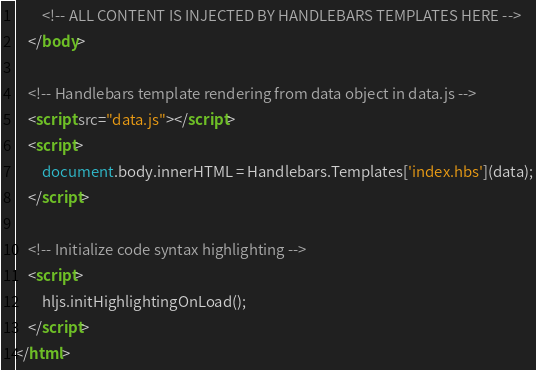Convert code to text. <code><loc_0><loc_0><loc_500><loc_500><_HTML_>		<!-- ALL CONTENT IS INJECTED BY HANDLEBARS TEMPLATES HERE -->
	</body>

	<!-- Handlebars template rendering from data object in data.js -->
	<script src="data.js"></script>
	<script>
		document.body.innerHTML = Handlebars.Templates['index.hbs'](data);
	</script>

	<!-- Initialize code syntax highlighting -->
	<script>
		hljs.initHighlightingOnLoad();
	</script>
</html>
</code> 